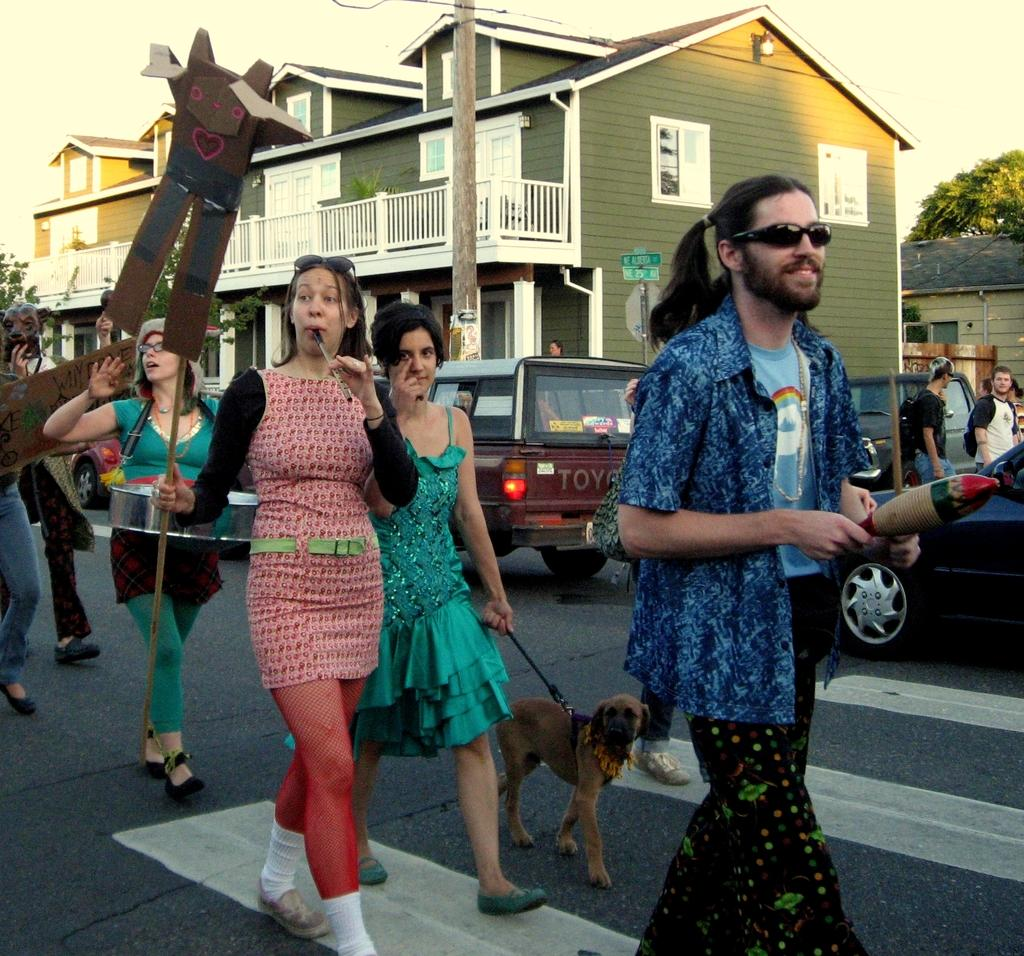What are the people in the image doing? The people in the image are walking on the road. What type of living creature is present in the image? There is an animal in the image. What can be seen in the background of the image? There are vehicles, buildings, trees, and the sky visible in the background of the image. What type of pot is being used by the achiever in the image? There is no achiever or pot present in the image. Can you tell me where the airport is located in the image? There is no airport present in the image. 